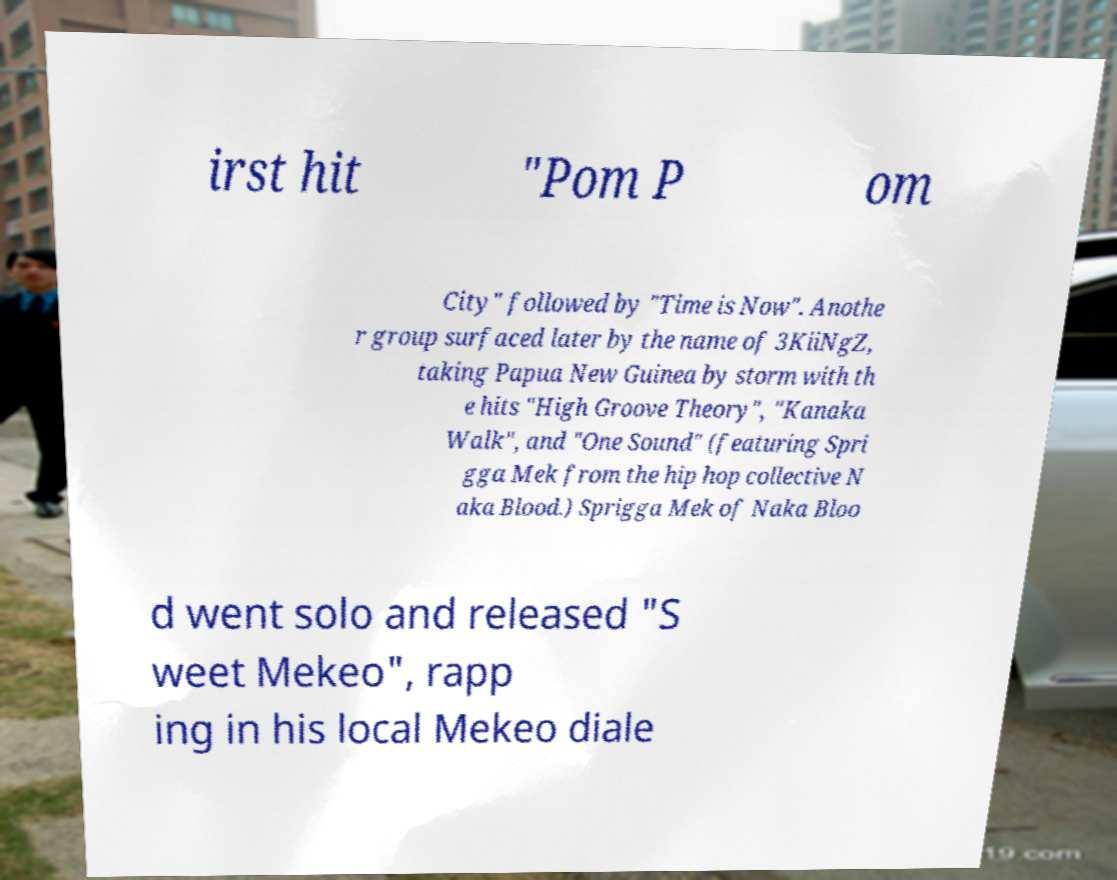Please read and relay the text visible in this image. What does it say? irst hit "Pom P om City" followed by "Time is Now". Anothe r group surfaced later by the name of 3KiiNgZ, taking Papua New Guinea by storm with th e hits "High Groove Theory", "Kanaka Walk", and "One Sound" (featuring Spri gga Mek from the hip hop collective N aka Blood.) Sprigga Mek of Naka Bloo d went solo and released "S weet Mekeo", rapp ing in his local Mekeo diale 